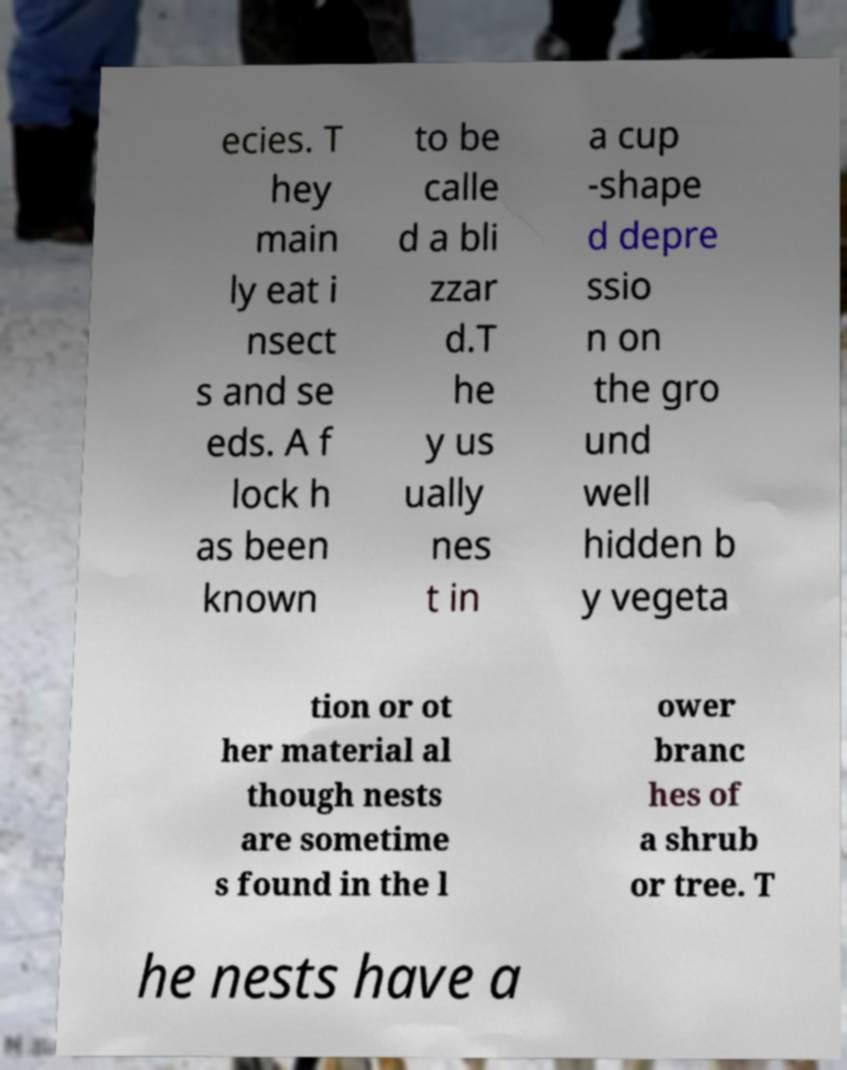Could you extract and type out the text from this image? ecies. T hey main ly eat i nsect s and se eds. A f lock h as been known to be calle d a bli zzar d.T he y us ually nes t in a cup -shape d depre ssio n on the gro und well hidden b y vegeta tion or ot her material al though nests are sometime s found in the l ower branc hes of a shrub or tree. T he nests have a 